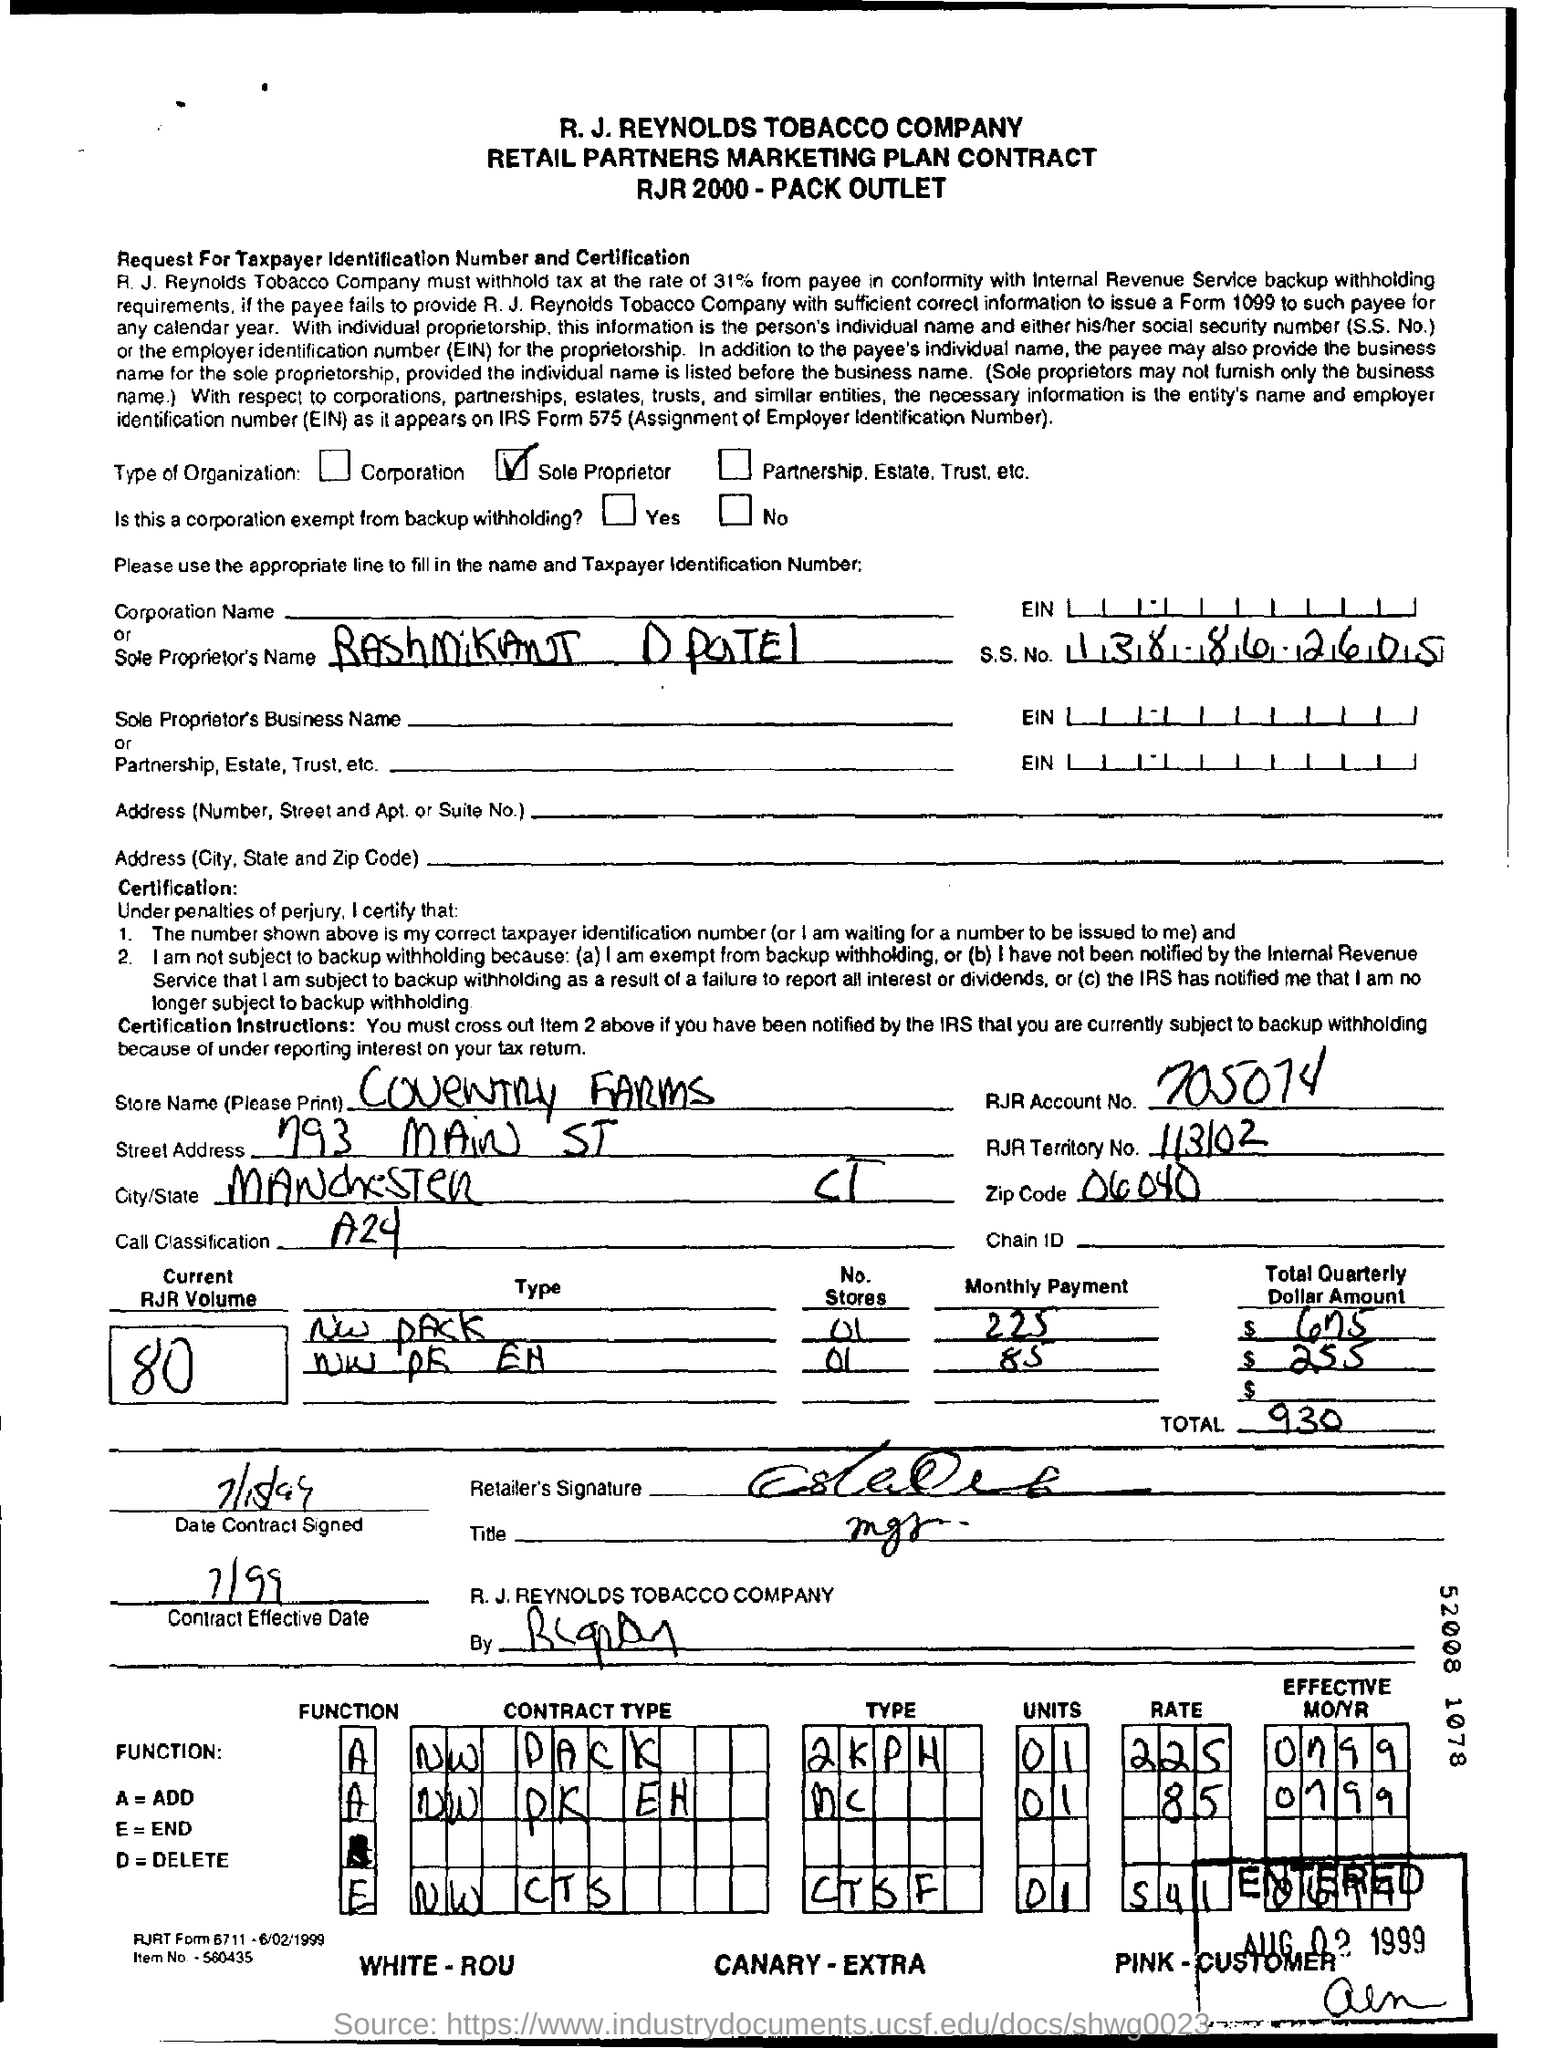Does this document appear to be complete? The document in the image has handwritten entries and some sections filled out, but other areas remain blank or partially filled. It's possible that this is a scanned copy of an original document, and it may not reflect its final state. Additionally, there are checkboxes, which are not marked, so it's not possible to determine whether all the necessary information was provided or actions had been taken based on the image alone.  What is the purpose of this document? The document functions as a contract between the R.J. Reynolds Tobacco Company and a retail partner. It outlines the agreement for marketing plans related to tobacco product sales. It specifies details like store name, payment amounts, types of marketing engagements, and the contractual function types such as additions, ends, or deletions of specified items or services within the contract's scope. 